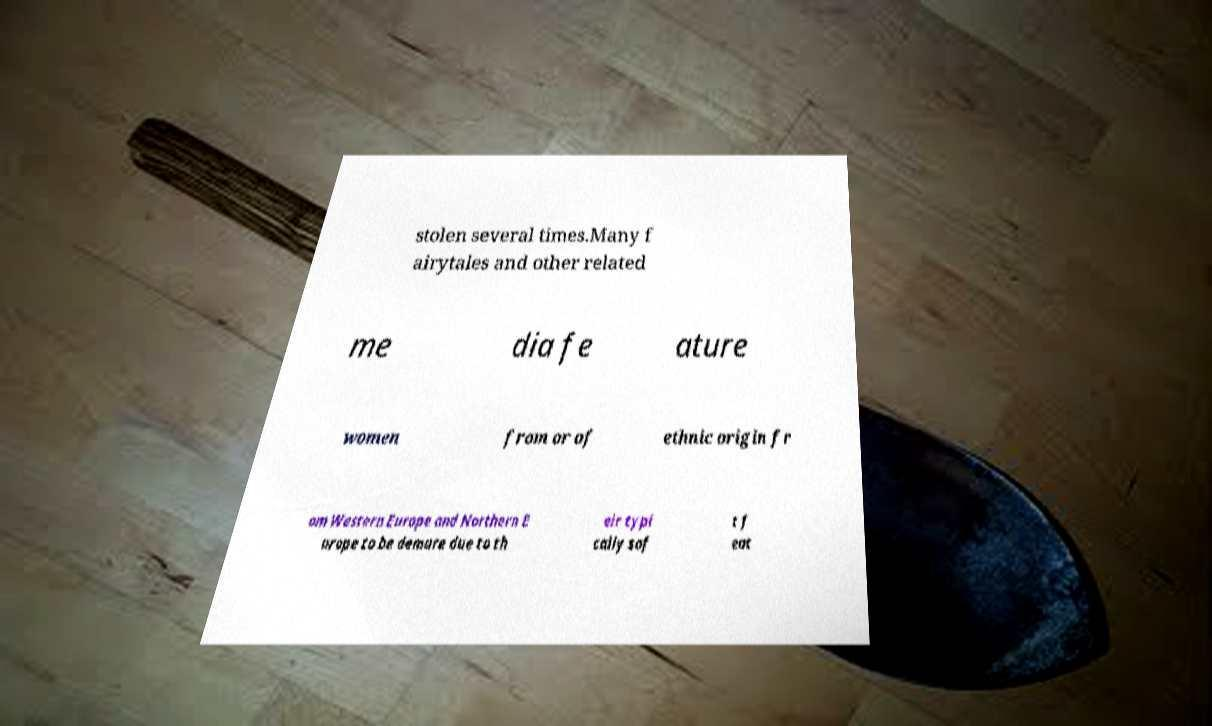Could you assist in decoding the text presented in this image and type it out clearly? stolen several times.Many f airytales and other related me dia fe ature women from or of ethnic origin fr om Western Europe and Northern E urope to be demure due to th eir typi cally sof t f eat 